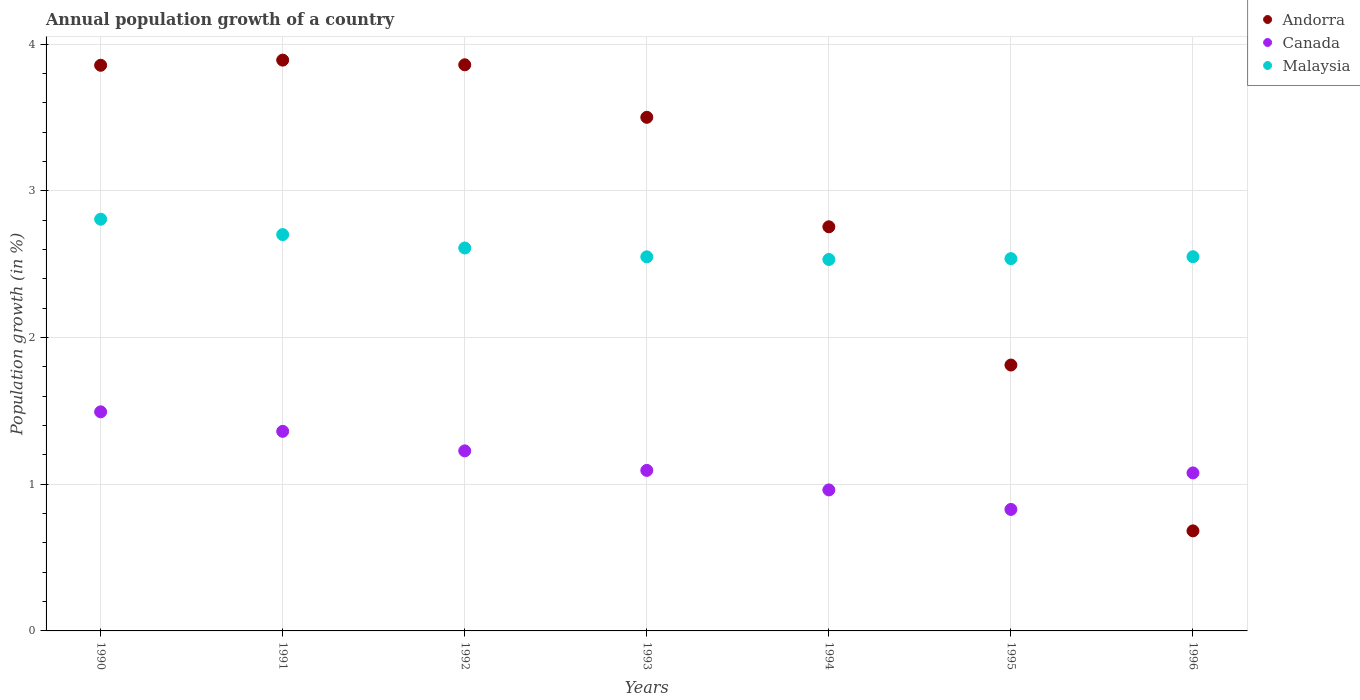Is the number of dotlines equal to the number of legend labels?
Your answer should be very brief. Yes. What is the annual population growth in Canada in 1992?
Your answer should be compact. 1.23. Across all years, what is the maximum annual population growth in Andorra?
Give a very brief answer. 3.89. Across all years, what is the minimum annual population growth in Andorra?
Your answer should be very brief. 0.68. What is the total annual population growth in Malaysia in the graph?
Offer a very short reply. 18.29. What is the difference between the annual population growth in Canada in 1991 and that in 1993?
Provide a short and direct response. 0.27. What is the difference between the annual population growth in Andorra in 1993 and the annual population growth in Malaysia in 1995?
Keep it short and to the point. 0.96. What is the average annual population growth in Malaysia per year?
Provide a succinct answer. 2.61. In the year 1991, what is the difference between the annual population growth in Canada and annual population growth in Andorra?
Offer a very short reply. -2.53. In how many years, is the annual population growth in Malaysia greater than 1.4 %?
Give a very brief answer. 7. What is the ratio of the annual population growth in Andorra in 1992 to that in 1996?
Your response must be concise. 5.66. Is the difference between the annual population growth in Canada in 1995 and 1996 greater than the difference between the annual population growth in Andorra in 1995 and 1996?
Your answer should be compact. No. What is the difference between the highest and the second highest annual population growth in Andorra?
Make the answer very short. 0.03. What is the difference between the highest and the lowest annual population growth in Andorra?
Your answer should be very brief. 3.21. How many years are there in the graph?
Your answer should be compact. 7. Does the graph contain grids?
Your answer should be compact. Yes. How are the legend labels stacked?
Provide a succinct answer. Vertical. What is the title of the graph?
Your answer should be very brief. Annual population growth of a country. What is the label or title of the X-axis?
Provide a short and direct response. Years. What is the label or title of the Y-axis?
Your response must be concise. Population growth (in %). What is the Population growth (in %) of Andorra in 1990?
Offer a very short reply. 3.86. What is the Population growth (in %) in Canada in 1990?
Give a very brief answer. 1.49. What is the Population growth (in %) in Malaysia in 1990?
Make the answer very short. 2.81. What is the Population growth (in %) in Andorra in 1991?
Offer a terse response. 3.89. What is the Population growth (in %) in Canada in 1991?
Offer a terse response. 1.36. What is the Population growth (in %) of Malaysia in 1991?
Keep it short and to the point. 2.7. What is the Population growth (in %) of Andorra in 1992?
Keep it short and to the point. 3.86. What is the Population growth (in %) of Canada in 1992?
Provide a short and direct response. 1.23. What is the Population growth (in %) of Malaysia in 1992?
Provide a succinct answer. 2.61. What is the Population growth (in %) of Andorra in 1993?
Provide a short and direct response. 3.5. What is the Population growth (in %) of Canada in 1993?
Your response must be concise. 1.09. What is the Population growth (in %) of Malaysia in 1993?
Give a very brief answer. 2.55. What is the Population growth (in %) of Andorra in 1994?
Keep it short and to the point. 2.76. What is the Population growth (in %) in Canada in 1994?
Ensure brevity in your answer.  0.96. What is the Population growth (in %) of Malaysia in 1994?
Make the answer very short. 2.53. What is the Population growth (in %) of Andorra in 1995?
Give a very brief answer. 1.81. What is the Population growth (in %) of Canada in 1995?
Offer a terse response. 0.83. What is the Population growth (in %) in Malaysia in 1995?
Provide a succinct answer. 2.54. What is the Population growth (in %) in Andorra in 1996?
Give a very brief answer. 0.68. What is the Population growth (in %) in Canada in 1996?
Your answer should be very brief. 1.08. What is the Population growth (in %) in Malaysia in 1996?
Your response must be concise. 2.55. Across all years, what is the maximum Population growth (in %) in Andorra?
Ensure brevity in your answer.  3.89. Across all years, what is the maximum Population growth (in %) in Canada?
Offer a very short reply. 1.49. Across all years, what is the maximum Population growth (in %) of Malaysia?
Provide a succinct answer. 2.81. Across all years, what is the minimum Population growth (in %) of Andorra?
Offer a very short reply. 0.68. Across all years, what is the minimum Population growth (in %) in Canada?
Offer a very short reply. 0.83. Across all years, what is the minimum Population growth (in %) of Malaysia?
Your response must be concise. 2.53. What is the total Population growth (in %) in Andorra in the graph?
Your answer should be very brief. 20.36. What is the total Population growth (in %) in Canada in the graph?
Provide a succinct answer. 8.04. What is the total Population growth (in %) in Malaysia in the graph?
Make the answer very short. 18.29. What is the difference between the Population growth (in %) in Andorra in 1990 and that in 1991?
Your response must be concise. -0.04. What is the difference between the Population growth (in %) in Canada in 1990 and that in 1991?
Ensure brevity in your answer.  0.13. What is the difference between the Population growth (in %) of Malaysia in 1990 and that in 1991?
Make the answer very short. 0.1. What is the difference between the Population growth (in %) in Andorra in 1990 and that in 1992?
Give a very brief answer. -0. What is the difference between the Population growth (in %) of Canada in 1990 and that in 1992?
Your answer should be very brief. 0.27. What is the difference between the Population growth (in %) of Malaysia in 1990 and that in 1992?
Your answer should be compact. 0.2. What is the difference between the Population growth (in %) of Andorra in 1990 and that in 1993?
Your response must be concise. 0.35. What is the difference between the Population growth (in %) in Canada in 1990 and that in 1993?
Make the answer very short. 0.4. What is the difference between the Population growth (in %) of Malaysia in 1990 and that in 1993?
Give a very brief answer. 0.26. What is the difference between the Population growth (in %) in Andorra in 1990 and that in 1994?
Provide a succinct answer. 1.1. What is the difference between the Population growth (in %) in Canada in 1990 and that in 1994?
Your answer should be compact. 0.53. What is the difference between the Population growth (in %) of Malaysia in 1990 and that in 1994?
Offer a terse response. 0.27. What is the difference between the Population growth (in %) of Andorra in 1990 and that in 1995?
Give a very brief answer. 2.04. What is the difference between the Population growth (in %) of Canada in 1990 and that in 1995?
Your answer should be very brief. 0.67. What is the difference between the Population growth (in %) in Malaysia in 1990 and that in 1995?
Provide a succinct answer. 0.27. What is the difference between the Population growth (in %) in Andorra in 1990 and that in 1996?
Offer a very short reply. 3.17. What is the difference between the Population growth (in %) of Canada in 1990 and that in 1996?
Offer a terse response. 0.42. What is the difference between the Population growth (in %) of Malaysia in 1990 and that in 1996?
Your answer should be compact. 0.26. What is the difference between the Population growth (in %) in Andorra in 1991 and that in 1992?
Provide a succinct answer. 0.03. What is the difference between the Population growth (in %) in Canada in 1991 and that in 1992?
Provide a short and direct response. 0.13. What is the difference between the Population growth (in %) in Malaysia in 1991 and that in 1992?
Your response must be concise. 0.09. What is the difference between the Population growth (in %) of Andorra in 1991 and that in 1993?
Make the answer very short. 0.39. What is the difference between the Population growth (in %) of Canada in 1991 and that in 1993?
Provide a short and direct response. 0.27. What is the difference between the Population growth (in %) in Malaysia in 1991 and that in 1993?
Offer a terse response. 0.15. What is the difference between the Population growth (in %) of Andorra in 1991 and that in 1994?
Your answer should be compact. 1.14. What is the difference between the Population growth (in %) of Canada in 1991 and that in 1994?
Offer a terse response. 0.4. What is the difference between the Population growth (in %) in Malaysia in 1991 and that in 1994?
Provide a succinct answer. 0.17. What is the difference between the Population growth (in %) of Andorra in 1991 and that in 1995?
Your answer should be compact. 2.08. What is the difference between the Population growth (in %) in Canada in 1991 and that in 1995?
Offer a very short reply. 0.53. What is the difference between the Population growth (in %) of Malaysia in 1991 and that in 1995?
Your response must be concise. 0.16. What is the difference between the Population growth (in %) in Andorra in 1991 and that in 1996?
Make the answer very short. 3.21. What is the difference between the Population growth (in %) of Canada in 1991 and that in 1996?
Keep it short and to the point. 0.28. What is the difference between the Population growth (in %) in Malaysia in 1991 and that in 1996?
Your answer should be compact. 0.15. What is the difference between the Population growth (in %) of Andorra in 1992 and that in 1993?
Provide a succinct answer. 0.36. What is the difference between the Population growth (in %) in Canada in 1992 and that in 1993?
Provide a succinct answer. 0.13. What is the difference between the Population growth (in %) of Malaysia in 1992 and that in 1993?
Make the answer very short. 0.06. What is the difference between the Population growth (in %) in Andorra in 1992 and that in 1994?
Ensure brevity in your answer.  1.1. What is the difference between the Population growth (in %) of Canada in 1992 and that in 1994?
Make the answer very short. 0.27. What is the difference between the Population growth (in %) in Malaysia in 1992 and that in 1994?
Your answer should be very brief. 0.08. What is the difference between the Population growth (in %) in Andorra in 1992 and that in 1995?
Ensure brevity in your answer.  2.05. What is the difference between the Population growth (in %) in Canada in 1992 and that in 1995?
Give a very brief answer. 0.4. What is the difference between the Population growth (in %) of Malaysia in 1992 and that in 1995?
Keep it short and to the point. 0.07. What is the difference between the Population growth (in %) of Andorra in 1992 and that in 1996?
Your answer should be compact. 3.18. What is the difference between the Population growth (in %) of Canada in 1992 and that in 1996?
Make the answer very short. 0.15. What is the difference between the Population growth (in %) in Malaysia in 1992 and that in 1996?
Keep it short and to the point. 0.06. What is the difference between the Population growth (in %) in Andorra in 1993 and that in 1994?
Ensure brevity in your answer.  0.75. What is the difference between the Population growth (in %) of Canada in 1993 and that in 1994?
Make the answer very short. 0.13. What is the difference between the Population growth (in %) in Malaysia in 1993 and that in 1994?
Your answer should be very brief. 0.02. What is the difference between the Population growth (in %) in Andorra in 1993 and that in 1995?
Your answer should be very brief. 1.69. What is the difference between the Population growth (in %) of Canada in 1993 and that in 1995?
Provide a short and direct response. 0.27. What is the difference between the Population growth (in %) of Malaysia in 1993 and that in 1995?
Make the answer very short. 0.01. What is the difference between the Population growth (in %) in Andorra in 1993 and that in 1996?
Offer a terse response. 2.82. What is the difference between the Population growth (in %) in Canada in 1993 and that in 1996?
Provide a short and direct response. 0.02. What is the difference between the Population growth (in %) of Malaysia in 1993 and that in 1996?
Your answer should be very brief. -0. What is the difference between the Population growth (in %) of Andorra in 1994 and that in 1995?
Keep it short and to the point. 0.94. What is the difference between the Population growth (in %) in Canada in 1994 and that in 1995?
Your answer should be compact. 0.13. What is the difference between the Population growth (in %) in Malaysia in 1994 and that in 1995?
Your response must be concise. -0.01. What is the difference between the Population growth (in %) of Andorra in 1994 and that in 1996?
Give a very brief answer. 2.07. What is the difference between the Population growth (in %) in Canada in 1994 and that in 1996?
Keep it short and to the point. -0.12. What is the difference between the Population growth (in %) of Malaysia in 1994 and that in 1996?
Provide a short and direct response. -0.02. What is the difference between the Population growth (in %) in Andorra in 1995 and that in 1996?
Give a very brief answer. 1.13. What is the difference between the Population growth (in %) in Canada in 1995 and that in 1996?
Your response must be concise. -0.25. What is the difference between the Population growth (in %) in Malaysia in 1995 and that in 1996?
Offer a terse response. -0.01. What is the difference between the Population growth (in %) in Andorra in 1990 and the Population growth (in %) in Canada in 1991?
Your answer should be compact. 2.5. What is the difference between the Population growth (in %) in Andorra in 1990 and the Population growth (in %) in Malaysia in 1991?
Keep it short and to the point. 1.15. What is the difference between the Population growth (in %) of Canada in 1990 and the Population growth (in %) of Malaysia in 1991?
Provide a short and direct response. -1.21. What is the difference between the Population growth (in %) of Andorra in 1990 and the Population growth (in %) of Canada in 1992?
Your answer should be compact. 2.63. What is the difference between the Population growth (in %) of Andorra in 1990 and the Population growth (in %) of Malaysia in 1992?
Your answer should be very brief. 1.25. What is the difference between the Population growth (in %) in Canada in 1990 and the Population growth (in %) in Malaysia in 1992?
Keep it short and to the point. -1.12. What is the difference between the Population growth (in %) of Andorra in 1990 and the Population growth (in %) of Canada in 1993?
Offer a terse response. 2.76. What is the difference between the Population growth (in %) in Andorra in 1990 and the Population growth (in %) in Malaysia in 1993?
Your answer should be very brief. 1.31. What is the difference between the Population growth (in %) in Canada in 1990 and the Population growth (in %) in Malaysia in 1993?
Make the answer very short. -1.06. What is the difference between the Population growth (in %) of Andorra in 1990 and the Population growth (in %) of Canada in 1994?
Keep it short and to the point. 2.89. What is the difference between the Population growth (in %) of Andorra in 1990 and the Population growth (in %) of Malaysia in 1994?
Your answer should be very brief. 1.32. What is the difference between the Population growth (in %) of Canada in 1990 and the Population growth (in %) of Malaysia in 1994?
Make the answer very short. -1.04. What is the difference between the Population growth (in %) in Andorra in 1990 and the Population growth (in %) in Canada in 1995?
Ensure brevity in your answer.  3.03. What is the difference between the Population growth (in %) of Andorra in 1990 and the Population growth (in %) of Malaysia in 1995?
Your response must be concise. 1.32. What is the difference between the Population growth (in %) of Canada in 1990 and the Population growth (in %) of Malaysia in 1995?
Make the answer very short. -1.04. What is the difference between the Population growth (in %) of Andorra in 1990 and the Population growth (in %) of Canada in 1996?
Provide a succinct answer. 2.78. What is the difference between the Population growth (in %) in Andorra in 1990 and the Population growth (in %) in Malaysia in 1996?
Provide a short and direct response. 1.31. What is the difference between the Population growth (in %) of Canada in 1990 and the Population growth (in %) of Malaysia in 1996?
Keep it short and to the point. -1.06. What is the difference between the Population growth (in %) of Andorra in 1991 and the Population growth (in %) of Canada in 1992?
Offer a very short reply. 2.66. What is the difference between the Population growth (in %) of Andorra in 1991 and the Population growth (in %) of Malaysia in 1992?
Offer a very short reply. 1.28. What is the difference between the Population growth (in %) in Canada in 1991 and the Population growth (in %) in Malaysia in 1992?
Provide a short and direct response. -1.25. What is the difference between the Population growth (in %) in Andorra in 1991 and the Population growth (in %) in Canada in 1993?
Make the answer very short. 2.8. What is the difference between the Population growth (in %) of Andorra in 1991 and the Population growth (in %) of Malaysia in 1993?
Keep it short and to the point. 1.34. What is the difference between the Population growth (in %) of Canada in 1991 and the Population growth (in %) of Malaysia in 1993?
Ensure brevity in your answer.  -1.19. What is the difference between the Population growth (in %) of Andorra in 1991 and the Population growth (in %) of Canada in 1994?
Your answer should be very brief. 2.93. What is the difference between the Population growth (in %) in Andorra in 1991 and the Population growth (in %) in Malaysia in 1994?
Your answer should be very brief. 1.36. What is the difference between the Population growth (in %) in Canada in 1991 and the Population growth (in %) in Malaysia in 1994?
Ensure brevity in your answer.  -1.17. What is the difference between the Population growth (in %) in Andorra in 1991 and the Population growth (in %) in Canada in 1995?
Your answer should be very brief. 3.06. What is the difference between the Population growth (in %) of Andorra in 1991 and the Population growth (in %) of Malaysia in 1995?
Provide a short and direct response. 1.35. What is the difference between the Population growth (in %) of Canada in 1991 and the Population growth (in %) of Malaysia in 1995?
Your answer should be very brief. -1.18. What is the difference between the Population growth (in %) in Andorra in 1991 and the Population growth (in %) in Canada in 1996?
Offer a terse response. 2.81. What is the difference between the Population growth (in %) of Andorra in 1991 and the Population growth (in %) of Malaysia in 1996?
Your answer should be very brief. 1.34. What is the difference between the Population growth (in %) in Canada in 1991 and the Population growth (in %) in Malaysia in 1996?
Your response must be concise. -1.19. What is the difference between the Population growth (in %) of Andorra in 1992 and the Population growth (in %) of Canada in 1993?
Your response must be concise. 2.77. What is the difference between the Population growth (in %) in Andorra in 1992 and the Population growth (in %) in Malaysia in 1993?
Keep it short and to the point. 1.31. What is the difference between the Population growth (in %) of Canada in 1992 and the Population growth (in %) of Malaysia in 1993?
Your response must be concise. -1.32. What is the difference between the Population growth (in %) of Andorra in 1992 and the Population growth (in %) of Canada in 1994?
Offer a very short reply. 2.9. What is the difference between the Population growth (in %) of Andorra in 1992 and the Population growth (in %) of Malaysia in 1994?
Give a very brief answer. 1.33. What is the difference between the Population growth (in %) in Canada in 1992 and the Population growth (in %) in Malaysia in 1994?
Your answer should be compact. -1.3. What is the difference between the Population growth (in %) of Andorra in 1992 and the Population growth (in %) of Canada in 1995?
Your response must be concise. 3.03. What is the difference between the Population growth (in %) in Andorra in 1992 and the Population growth (in %) in Malaysia in 1995?
Give a very brief answer. 1.32. What is the difference between the Population growth (in %) of Canada in 1992 and the Population growth (in %) of Malaysia in 1995?
Give a very brief answer. -1.31. What is the difference between the Population growth (in %) in Andorra in 1992 and the Population growth (in %) in Canada in 1996?
Provide a short and direct response. 2.78. What is the difference between the Population growth (in %) in Andorra in 1992 and the Population growth (in %) in Malaysia in 1996?
Your answer should be very brief. 1.31. What is the difference between the Population growth (in %) of Canada in 1992 and the Population growth (in %) of Malaysia in 1996?
Offer a terse response. -1.32. What is the difference between the Population growth (in %) in Andorra in 1993 and the Population growth (in %) in Canada in 1994?
Your answer should be compact. 2.54. What is the difference between the Population growth (in %) of Andorra in 1993 and the Population growth (in %) of Malaysia in 1994?
Your response must be concise. 0.97. What is the difference between the Population growth (in %) of Canada in 1993 and the Population growth (in %) of Malaysia in 1994?
Your answer should be compact. -1.44. What is the difference between the Population growth (in %) of Andorra in 1993 and the Population growth (in %) of Canada in 1995?
Offer a terse response. 2.67. What is the difference between the Population growth (in %) of Andorra in 1993 and the Population growth (in %) of Malaysia in 1995?
Your answer should be compact. 0.96. What is the difference between the Population growth (in %) in Canada in 1993 and the Population growth (in %) in Malaysia in 1995?
Your answer should be compact. -1.44. What is the difference between the Population growth (in %) of Andorra in 1993 and the Population growth (in %) of Canada in 1996?
Offer a terse response. 2.42. What is the difference between the Population growth (in %) in Andorra in 1993 and the Population growth (in %) in Malaysia in 1996?
Offer a very short reply. 0.95. What is the difference between the Population growth (in %) in Canada in 1993 and the Population growth (in %) in Malaysia in 1996?
Your answer should be very brief. -1.46. What is the difference between the Population growth (in %) of Andorra in 1994 and the Population growth (in %) of Canada in 1995?
Your answer should be compact. 1.93. What is the difference between the Population growth (in %) in Andorra in 1994 and the Population growth (in %) in Malaysia in 1995?
Offer a terse response. 0.22. What is the difference between the Population growth (in %) in Canada in 1994 and the Population growth (in %) in Malaysia in 1995?
Make the answer very short. -1.58. What is the difference between the Population growth (in %) of Andorra in 1994 and the Population growth (in %) of Canada in 1996?
Keep it short and to the point. 1.68. What is the difference between the Population growth (in %) in Andorra in 1994 and the Population growth (in %) in Malaysia in 1996?
Make the answer very short. 0.2. What is the difference between the Population growth (in %) of Canada in 1994 and the Population growth (in %) of Malaysia in 1996?
Offer a very short reply. -1.59. What is the difference between the Population growth (in %) of Andorra in 1995 and the Population growth (in %) of Canada in 1996?
Provide a short and direct response. 0.74. What is the difference between the Population growth (in %) in Andorra in 1995 and the Population growth (in %) in Malaysia in 1996?
Your answer should be very brief. -0.74. What is the difference between the Population growth (in %) of Canada in 1995 and the Population growth (in %) of Malaysia in 1996?
Ensure brevity in your answer.  -1.72. What is the average Population growth (in %) of Andorra per year?
Your answer should be compact. 2.91. What is the average Population growth (in %) in Canada per year?
Your response must be concise. 1.15. What is the average Population growth (in %) in Malaysia per year?
Your response must be concise. 2.61. In the year 1990, what is the difference between the Population growth (in %) in Andorra and Population growth (in %) in Canada?
Your answer should be very brief. 2.36. In the year 1990, what is the difference between the Population growth (in %) of Andorra and Population growth (in %) of Malaysia?
Make the answer very short. 1.05. In the year 1990, what is the difference between the Population growth (in %) in Canada and Population growth (in %) in Malaysia?
Give a very brief answer. -1.31. In the year 1991, what is the difference between the Population growth (in %) of Andorra and Population growth (in %) of Canada?
Ensure brevity in your answer.  2.53. In the year 1991, what is the difference between the Population growth (in %) of Andorra and Population growth (in %) of Malaysia?
Give a very brief answer. 1.19. In the year 1991, what is the difference between the Population growth (in %) in Canada and Population growth (in %) in Malaysia?
Your response must be concise. -1.34. In the year 1992, what is the difference between the Population growth (in %) in Andorra and Population growth (in %) in Canada?
Make the answer very short. 2.63. In the year 1992, what is the difference between the Population growth (in %) of Andorra and Population growth (in %) of Malaysia?
Provide a short and direct response. 1.25. In the year 1992, what is the difference between the Population growth (in %) of Canada and Population growth (in %) of Malaysia?
Provide a succinct answer. -1.38. In the year 1993, what is the difference between the Population growth (in %) of Andorra and Population growth (in %) of Canada?
Provide a succinct answer. 2.41. In the year 1993, what is the difference between the Population growth (in %) of Andorra and Population growth (in %) of Malaysia?
Your answer should be very brief. 0.95. In the year 1993, what is the difference between the Population growth (in %) in Canada and Population growth (in %) in Malaysia?
Keep it short and to the point. -1.46. In the year 1994, what is the difference between the Population growth (in %) of Andorra and Population growth (in %) of Canada?
Your answer should be very brief. 1.79. In the year 1994, what is the difference between the Population growth (in %) of Andorra and Population growth (in %) of Malaysia?
Your response must be concise. 0.22. In the year 1994, what is the difference between the Population growth (in %) of Canada and Population growth (in %) of Malaysia?
Your response must be concise. -1.57. In the year 1995, what is the difference between the Population growth (in %) of Andorra and Population growth (in %) of Canada?
Offer a terse response. 0.98. In the year 1995, what is the difference between the Population growth (in %) of Andorra and Population growth (in %) of Malaysia?
Your response must be concise. -0.73. In the year 1995, what is the difference between the Population growth (in %) in Canada and Population growth (in %) in Malaysia?
Make the answer very short. -1.71. In the year 1996, what is the difference between the Population growth (in %) in Andorra and Population growth (in %) in Canada?
Give a very brief answer. -0.4. In the year 1996, what is the difference between the Population growth (in %) in Andorra and Population growth (in %) in Malaysia?
Provide a short and direct response. -1.87. In the year 1996, what is the difference between the Population growth (in %) of Canada and Population growth (in %) of Malaysia?
Ensure brevity in your answer.  -1.47. What is the ratio of the Population growth (in %) in Andorra in 1990 to that in 1991?
Provide a succinct answer. 0.99. What is the ratio of the Population growth (in %) in Canada in 1990 to that in 1991?
Offer a very short reply. 1.1. What is the ratio of the Population growth (in %) in Malaysia in 1990 to that in 1991?
Provide a succinct answer. 1.04. What is the ratio of the Population growth (in %) of Andorra in 1990 to that in 1992?
Offer a very short reply. 1. What is the ratio of the Population growth (in %) in Canada in 1990 to that in 1992?
Make the answer very short. 1.22. What is the ratio of the Population growth (in %) in Malaysia in 1990 to that in 1992?
Give a very brief answer. 1.08. What is the ratio of the Population growth (in %) of Andorra in 1990 to that in 1993?
Ensure brevity in your answer.  1.1. What is the ratio of the Population growth (in %) in Canada in 1990 to that in 1993?
Your response must be concise. 1.36. What is the ratio of the Population growth (in %) of Malaysia in 1990 to that in 1993?
Make the answer very short. 1.1. What is the ratio of the Population growth (in %) of Andorra in 1990 to that in 1994?
Your answer should be compact. 1.4. What is the ratio of the Population growth (in %) of Canada in 1990 to that in 1994?
Your answer should be compact. 1.55. What is the ratio of the Population growth (in %) in Malaysia in 1990 to that in 1994?
Your answer should be very brief. 1.11. What is the ratio of the Population growth (in %) in Andorra in 1990 to that in 1995?
Provide a succinct answer. 2.13. What is the ratio of the Population growth (in %) in Canada in 1990 to that in 1995?
Keep it short and to the point. 1.8. What is the ratio of the Population growth (in %) in Malaysia in 1990 to that in 1995?
Offer a very short reply. 1.11. What is the ratio of the Population growth (in %) in Andorra in 1990 to that in 1996?
Your answer should be compact. 5.65. What is the ratio of the Population growth (in %) in Canada in 1990 to that in 1996?
Provide a succinct answer. 1.39. What is the ratio of the Population growth (in %) of Malaysia in 1990 to that in 1996?
Provide a succinct answer. 1.1. What is the ratio of the Population growth (in %) in Andorra in 1991 to that in 1992?
Give a very brief answer. 1.01. What is the ratio of the Population growth (in %) of Canada in 1991 to that in 1992?
Keep it short and to the point. 1.11. What is the ratio of the Population growth (in %) of Malaysia in 1991 to that in 1992?
Keep it short and to the point. 1.03. What is the ratio of the Population growth (in %) of Andorra in 1991 to that in 1993?
Provide a succinct answer. 1.11. What is the ratio of the Population growth (in %) of Canada in 1991 to that in 1993?
Keep it short and to the point. 1.24. What is the ratio of the Population growth (in %) in Malaysia in 1991 to that in 1993?
Keep it short and to the point. 1.06. What is the ratio of the Population growth (in %) of Andorra in 1991 to that in 1994?
Your answer should be very brief. 1.41. What is the ratio of the Population growth (in %) in Canada in 1991 to that in 1994?
Your answer should be very brief. 1.42. What is the ratio of the Population growth (in %) in Malaysia in 1991 to that in 1994?
Offer a very short reply. 1.07. What is the ratio of the Population growth (in %) in Andorra in 1991 to that in 1995?
Your answer should be very brief. 2.15. What is the ratio of the Population growth (in %) in Canada in 1991 to that in 1995?
Your answer should be compact. 1.64. What is the ratio of the Population growth (in %) in Malaysia in 1991 to that in 1995?
Offer a terse response. 1.06. What is the ratio of the Population growth (in %) of Andorra in 1991 to that in 1996?
Your response must be concise. 5.71. What is the ratio of the Population growth (in %) in Canada in 1991 to that in 1996?
Your answer should be compact. 1.26. What is the ratio of the Population growth (in %) in Malaysia in 1991 to that in 1996?
Offer a very short reply. 1.06. What is the ratio of the Population growth (in %) of Andorra in 1992 to that in 1993?
Keep it short and to the point. 1.1. What is the ratio of the Population growth (in %) of Canada in 1992 to that in 1993?
Provide a succinct answer. 1.12. What is the ratio of the Population growth (in %) of Malaysia in 1992 to that in 1993?
Offer a very short reply. 1.02. What is the ratio of the Population growth (in %) in Andorra in 1992 to that in 1994?
Keep it short and to the point. 1.4. What is the ratio of the Population growth (in %) in Canada in 1992 to that in 1994?
Provide a succinct answer. 1.28. What is the ratio of the Population growth (in %) of Malaysia in 1992 to that in 1994?
Your response must be concise. 1.03. What is the ratio of the Population growth (in %) of Andorra in 1992 to that in 1995?
Offer a very short reply. 2.13. What is the ratio of the Population growth (in %) in Canada in 1992 to that in 1995?
Your answer should be compact. 1.48. What is the ratio of the Population growth (in %) of Malaysia in 1992 to that in 1995?
Offer a very short reply. 1.03. What is the ratio of the Population growth (in %) of Andorra in 1992 to that in 1996?
Make the answer very short. 5.66. What is the ratio of the Population growth (in %) of Canada in 1992 to that in 1996?
Provide a succinct answer. 1.14. What is the ratio of the Population growth (in %) in Malaysia in 1992 to that in 1996?
Ensure brevity in your answer.  1.02. What is the ratio of the Population growth (in %) of Andorra in 1993 to that in 1994?
Your response must be concise. 1.27. What is the ratio of the Population growth (in %) in Canada in 1993 to that in 1994?
Keep it short and to the point. 1.14. What is the ratio of the Population growth (in %) in Malaysia in 1993 to that in 1994?
Your answer should be very brief. 1.01. What is the ratio of the Population growth (in %) of Andorra in 1993 to that in 1995?
Provide a short and direct response. 1.93. What is the ratio of the Population growth (in %) in Canada in 1993 to that in 1995?
Offer a terse response. 1.32. What is the ratio of the Population growth (in %) of Malaysia in 1993 to that in 1995?
Your answer should be compact. 1. What is the ratio of the Population growth (in %) in Andorra in 1993 to that in 1996?
Your answer should be compact. 5.13. What is the ratio of the Population growth (in %) of Canada in 1993 to that in 1996?
Your answer should be compact. 1.02. What is the ratio of the Population growth (in %) of Andorra in 1994 to that in 1995?
Offer a terse response. 1.52. What is the ratio of the Population growth (in %) of Canada in 1994 to that in 1995?
Your response must be concise. 1.16. What is the ratio of the Population growth (in %) of Andorra in 1994 to that in 1996?
Your answer should be compact. 4.04. What is the ratio of the Population growth (in %) of Canada in 1994 to that in 1996?
Your response must be concise. 0.89. What is the ratio of the Population growth (in %) of Andorra in 1995 to that in 1996?
Give a very brief answer. 2.66. What is the ratio of the Population growth (in %) of Canada in 1995 to that in 1996?
Your answer should be compact. 0.77. What is the ratio of the Population growth (in %) in Malaysia in 1995 to that in 1996?
Ensure brevity in your answer.  0.99. What is the difference between the highest and the second highest Population growth (in %) of Andorra?
Offer a terse response. 0.03. What is the difference between the highest and the second highest Population growth (in %) of Canada?
Provide a succinct answer. 0.13. What is the difference between the highest and the second highest Population growth (in %) in Malaysia?
Provide a short and direct response. 0.1. What is the difference between the highest and the lowest Population growth (in %) in Andorra?
Offer a very short reply. 3.21. What is the difference between the highest and the lowest Population growth (in %) of Canada?
Make the answer very short. 0.67. What is the difference between the highest and the lowest Population growth (in %) in Malaysia?
Ensure brevity in your answer.  0.27. 